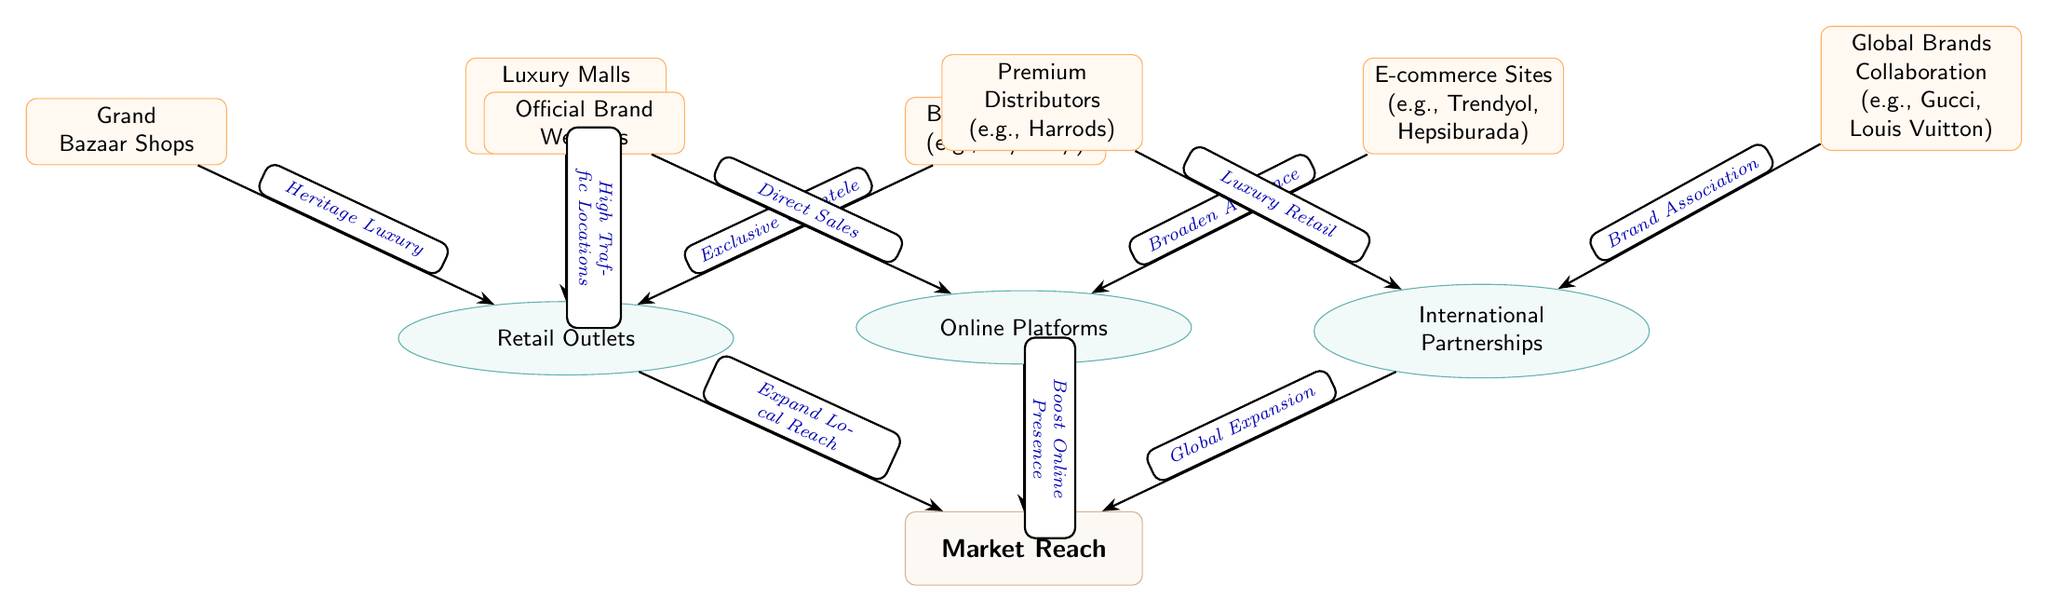What are the three main categories of distribution channels in Turkish luxury goods? The diagram identifies three main categories: Retail Outlets, Online Platforms, and International Partnerships. These categories are clearly mentioned as the primary nodes connected to the "Market Reach" node.
Answer: Retail Outlets, Online Platforms, International Partnerships How many subcategories are listed under Retail Outlets? In the diagram, Retail Outlets includes three subcategories: Grand Bazaar Shops, Luxury Malls (e.g., Istanbul Airport Mall), and Boutique Stores (e.g., Nişantaşı). Each subcategory is represented as a node under this category.
Answer: 3 Which subcategory of Online Platforms is associated with direct sales? The subcategory "Official Brand Websites" is connected to the Online Platforms node and is specifically labeled as having direct sales functionality as indicated by the edge labeled "Direct Sales."
Answer: Official Brand Websites What edge phrase indicates the connection between Boutique Stores and Retail Outlets? The phrase "Exclusive Clientele" is found on the edge that connects the Boutique Stores subcategory to the Retail Outlets category, representing the reason for this relationship.
Answer: Exclusive Clientele What kind of expansion do International Partnerships contribute to the market? The relationship indicated between International Partnerships and Market Reach is labeled as "Global Expansion," outlining the role of this category in reaching a broader market.
Answer: Global Expansion What are the two subcategories under International Partnerships? The subcategories listed under International Partnerships are Premium Distributors (e.g., Harrods) and Global Brands Collaboration (e.g., Gucci, Louis Vuitton). Both subcategories are positioned as nodes under the International Partnerships category.
Answer: Premium Distributors, Global Brands Collaboration 